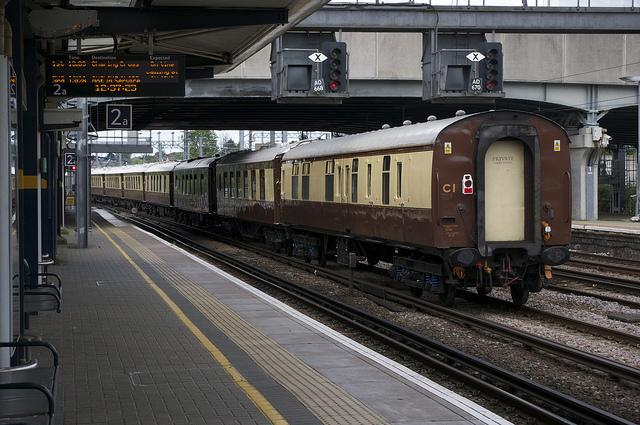What are the passengers told to wait behind? Please explain your reasoning. yellow line. The line and color is frequently used in train stations to bring riders attention to the fact they should wait a fair distance away from the approaching train to avoid injury. 